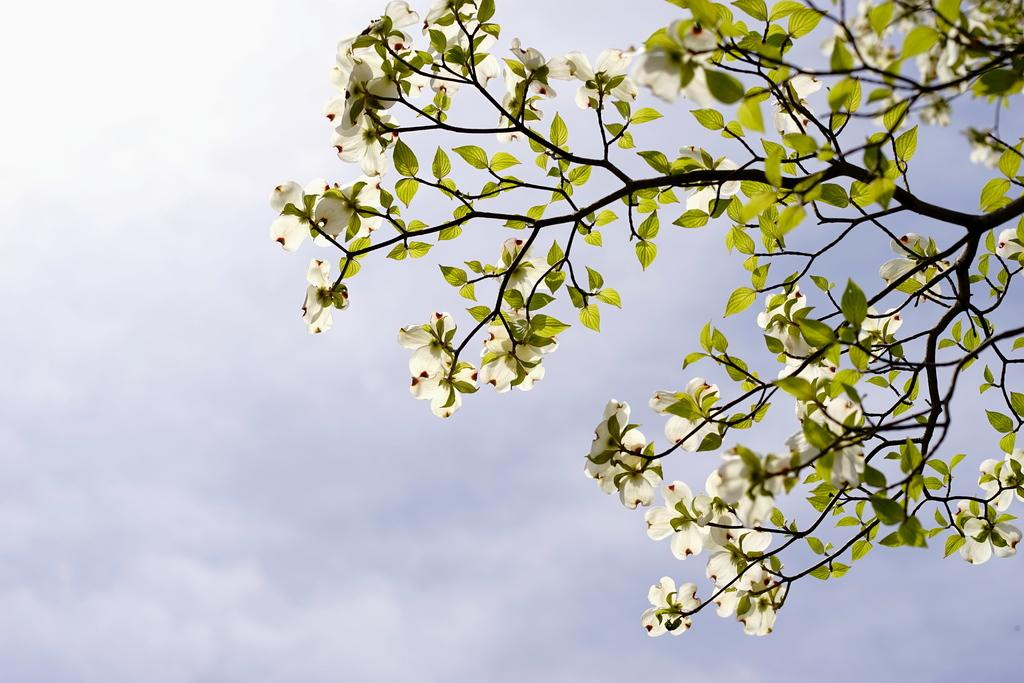What can be seen in the image that is related to plants? There are branches with flowers and leaves in the image. What part of the natural environment is visible in the background of the image? The sky is visible in the background of the image. How many trucks can be seen carrying glue in the image? There are no trucks or glue present in the image; it features branches with flowers and leaves against a sky background. 